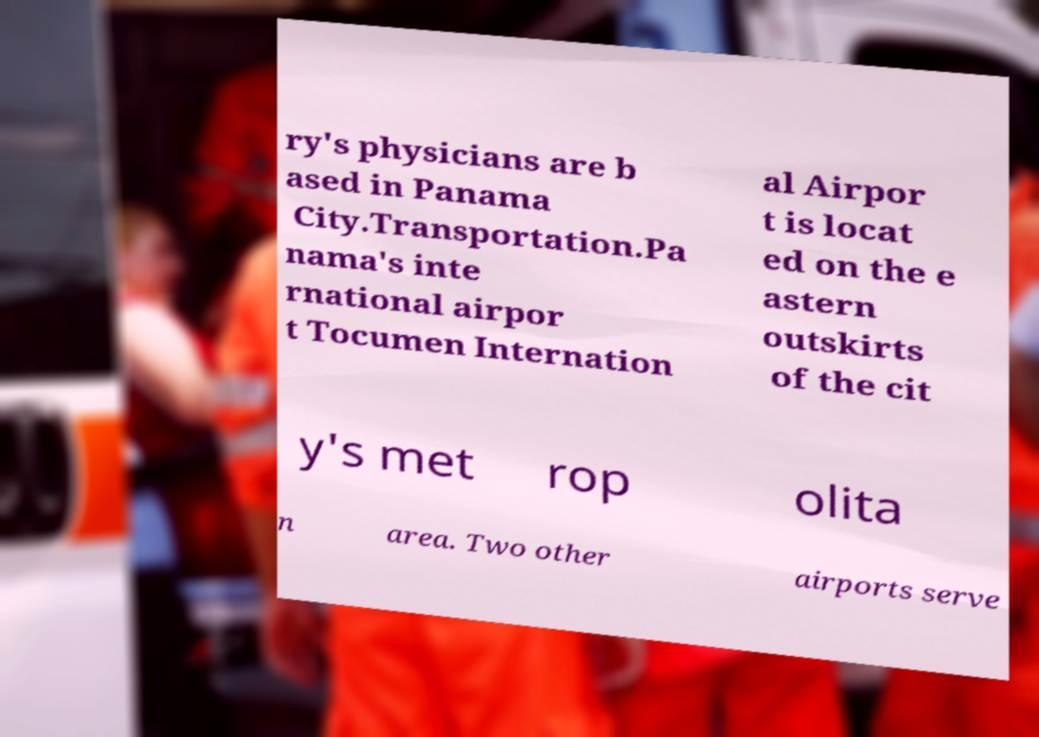Could you assist in decoding the text presented in this image and type it out clearly? ry's physicians are b ased in Panama City.Transportation.Pa nama's inte rnational airpor t Tocumen Internation al Airpor t is locat ed on the e astern outskirts of the cit y's met rop olita n area. Two other airports serve 